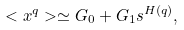Convert formula to latex. <formula><loc_0><loc_0><loc_500><loc_500>< x ^ { q } > \simeq G _ { 0 } + G _ { 1 } s ^ { H ( q ) } ,</formula> 